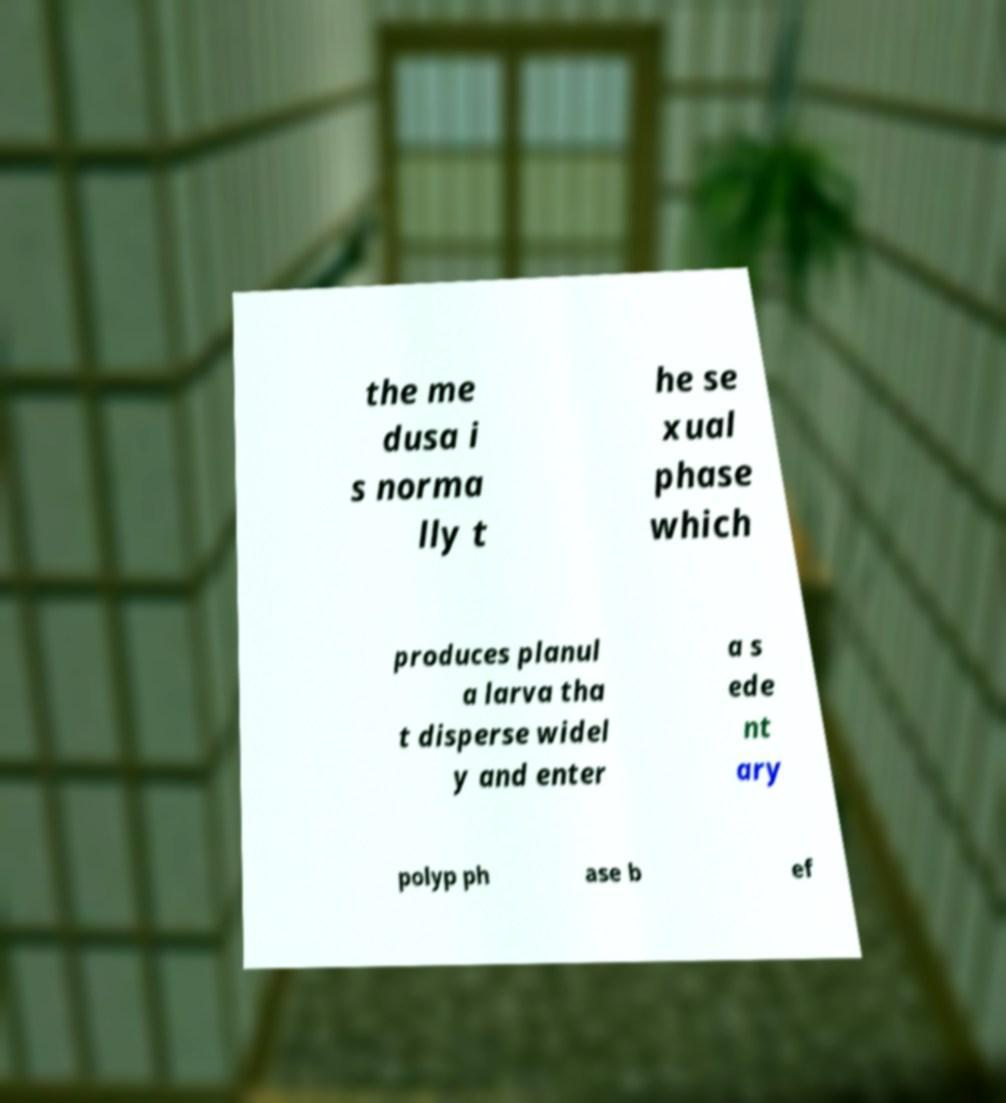Could you extract and type out the text from this image? the me dusa i s norma lly t he se xual phase which produces planul a larva tha t disperse widel y and enter a s ede nt ary polyp ph ase b ef 